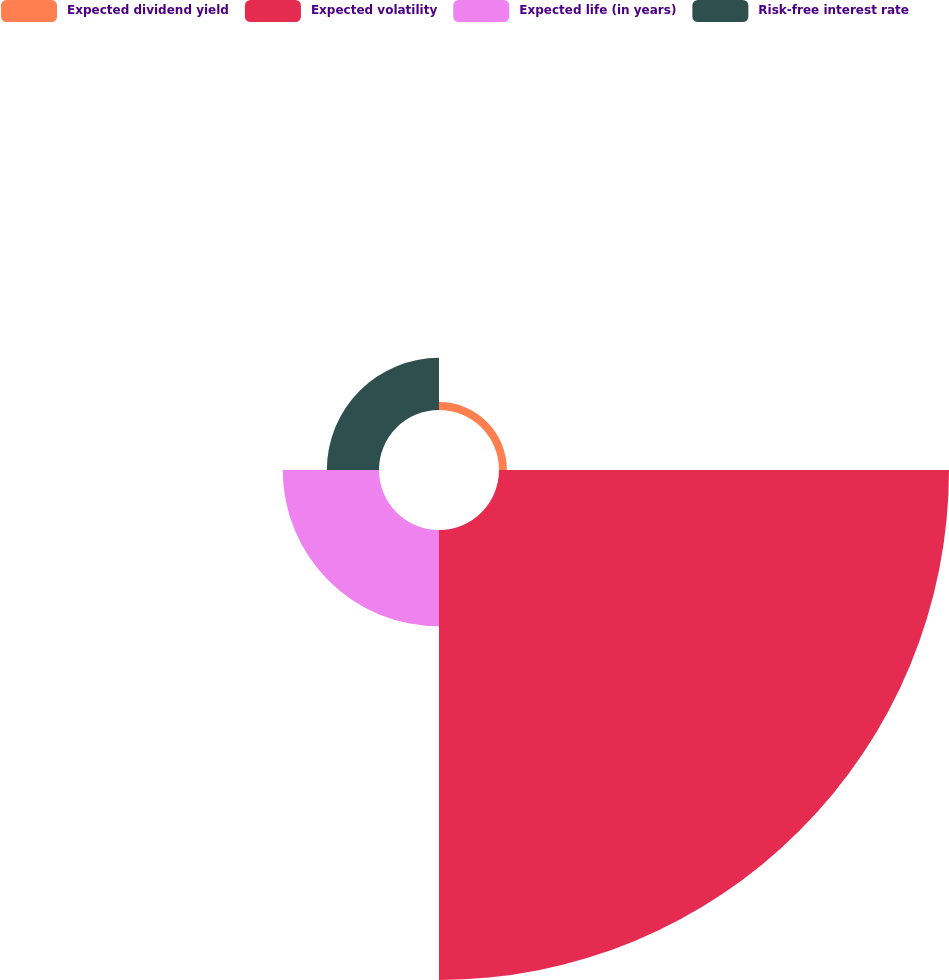<chart> <loc_0><loc_0><loc_500><loc_500><pie_chart><fcel>Expected dividend yield<fcel>Expected volatility<fcel>Expected life (in years)<fcel>Risk-free interest rate<nl><fcel>1.31%<fcel>74.21%<fcel>15.88%<fcel>8.6%<nl></chart> 